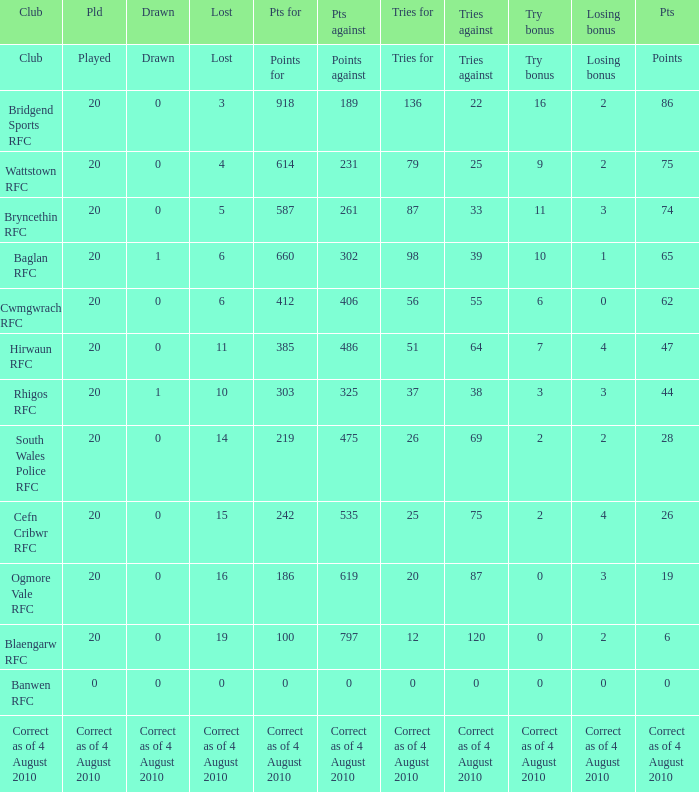What is drawn when the club is hirwaun rfc? 0.0. 